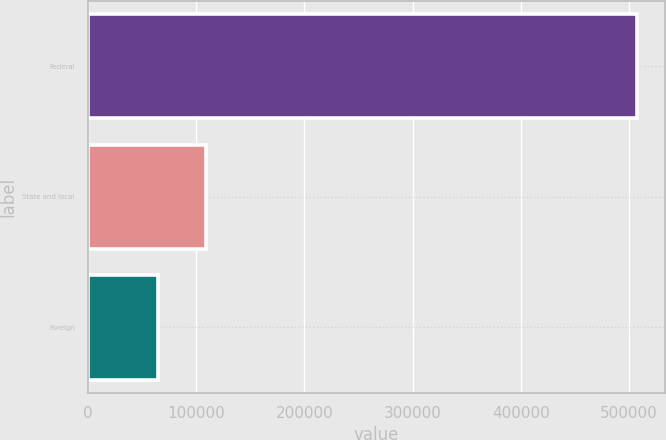<chart> <loc_0><loc_0><loc_500><loc_500><bar_chart><fcel>Federal<fcel>State and local<fcel>Foreign<nl><fcel>507411<fcel>109205<fcel>64960<nl></chart> 